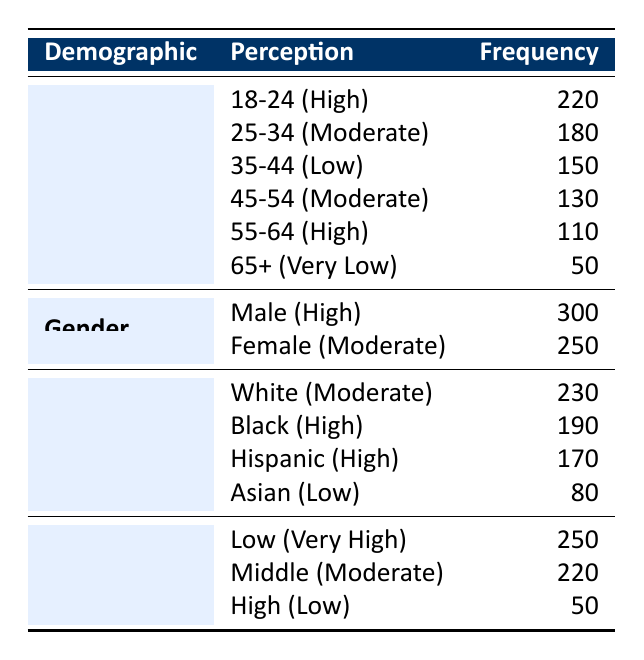What is the frequency of high perception in the 18-24 age group? The table indicates that in the age group of 18-24, the perception is categorized as "High" with a frequency of 220.
Answer: 220 How many respondents perceive crime rates as "Moderate" among females? The table shows that for females, the perception of crime rates is categorized as "Moderate" with a frequency of 250.
Answer: 250 What is the total frequency for individuals with a "Very High" income perception? The frequency for individuals with a "Very High" income perception is 250, as listed in the income level section of the table.
Answer: 250 Which age group has the lowest frequency of perception, and what is that frequency? The age group 65+, categorized with a "Very Low" perception, has the lowest frequency with a count of 50, according to the age group section of the table.
Answer: 50 Is there a higher perception of crime rates among males or females? The table shows that males have a "High" perception with a frequency of 300, while females have a "Moderate" perception with a frequency of 250. Therefore, males have a higher perception.
Answer: Yes What is the difference in frequency between the perception of "High" among males and "Very Low" among the 65+ age group? Males have a "High" perception with a frequency of 300, while the 65+ age group has a "Very Low" perception with a frequency of 50. The difference is calculated as 300 - 50 = 250.
Answer: 250 What is the average frequency of perceptions categorized as "High" across different demographics? The high perceptions come from the following groups: 220 (age 18-24), 300 (male), 190 (Black), and 170 (Hispanic). Adding these up gives 220 + 300 + 190 + 170 = 880. There are 4 data points, so the average is 880 / 4 = 220.
Answer: 220 Which race demographic has the highest frequency of crime perception and what is that frequency? Among race demographics, males have the highest frequency of 300 with a "High" perception. The next highest is "Moderate" for White at 230. So, the highest is Black at 190.
Answer: Male, 300 Is it true that all income levels have a frequency of at least 100? The frequency for the high-income level is only 50, which is below 100. Therefore, not all income levels meet this criteria.
Answer: No 